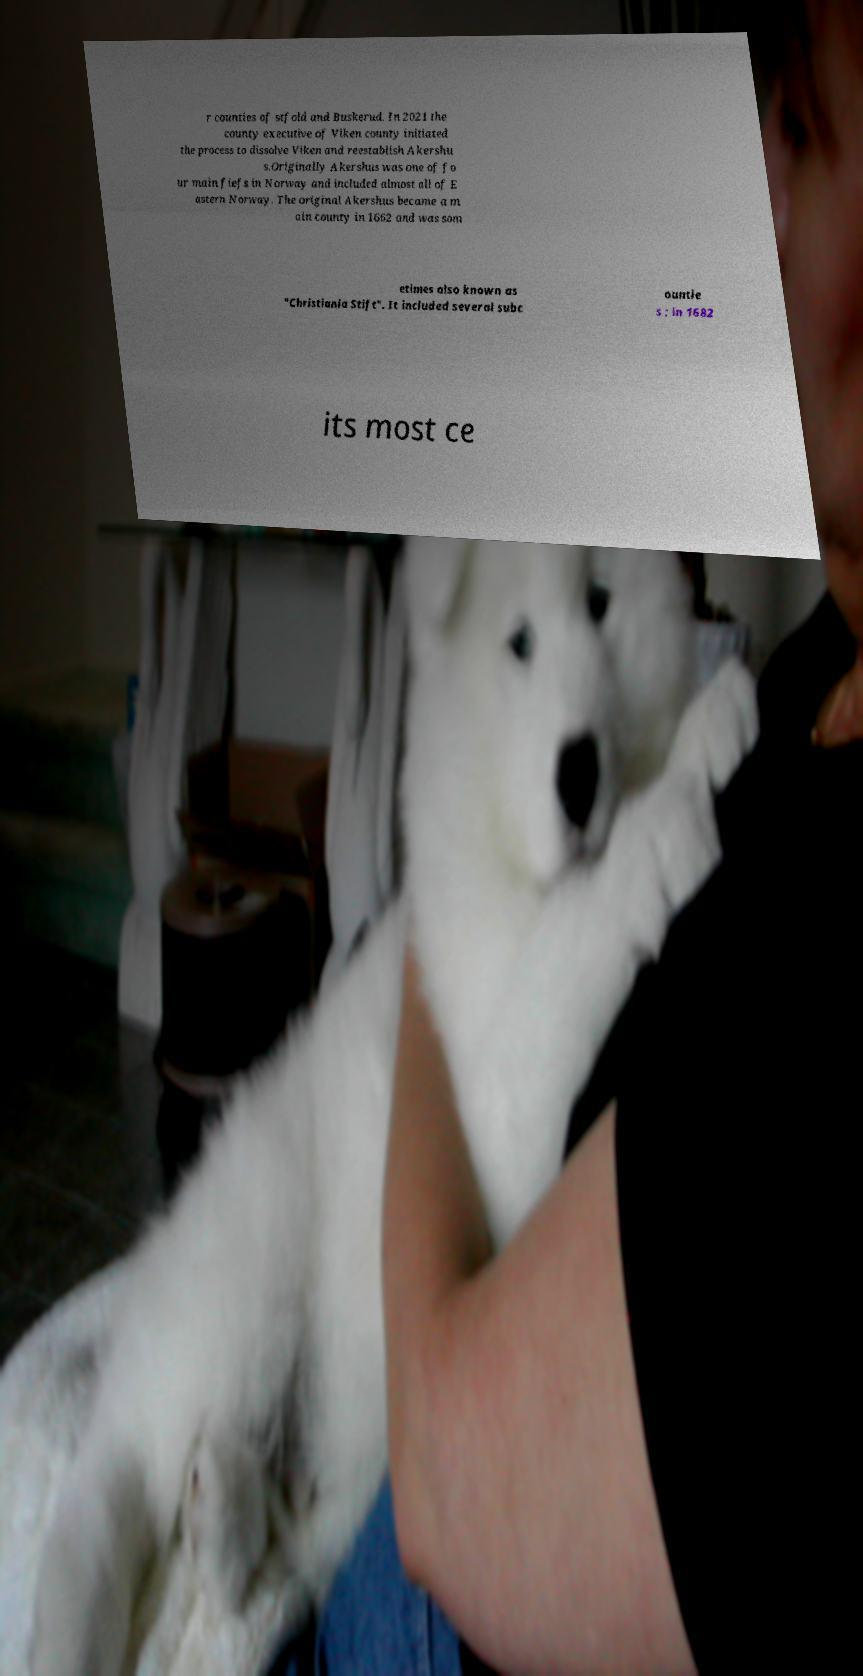Can you accurately transcribe the text from the provided image for me? r counties of stfold and Buskerud. In 2021 the county executive of Viken county initiated the process to dissolve Viken and reestablish Akershu s.Originally Akershus was one of fo ur main fiefs in Norway and included almost all of E astern Norway. The original Akershus became a m ain county in 1662 and was som etimes also known as "Christiania Stift". It included several subc ountie s ; in 1682 its most ce 